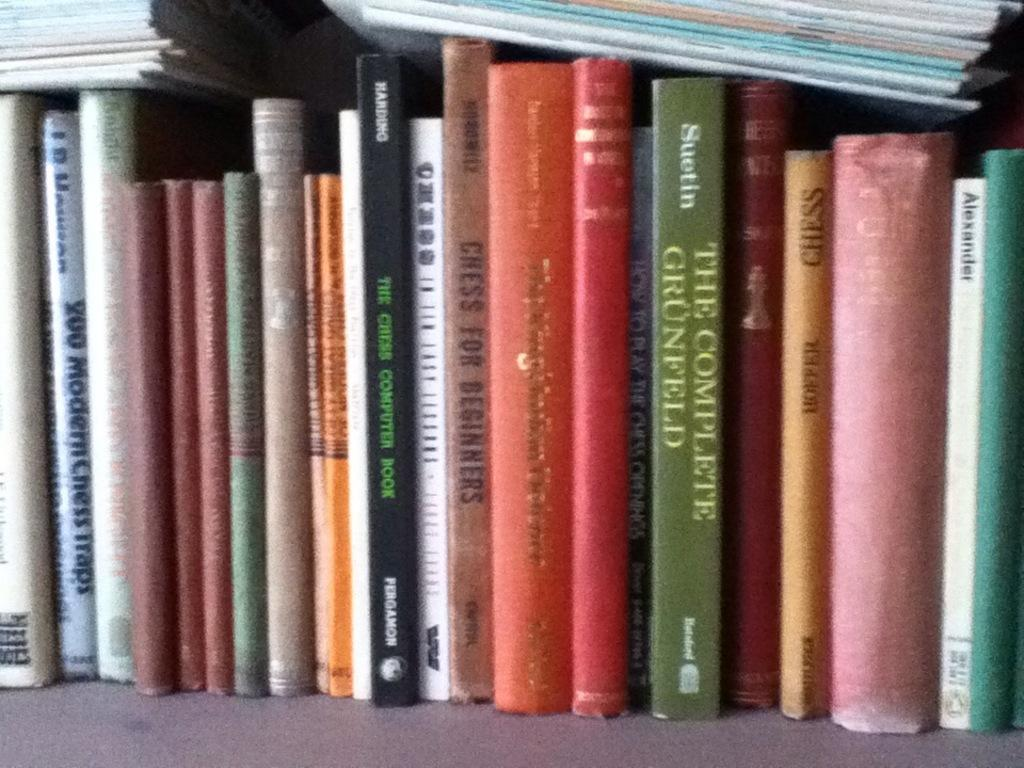<image>
Create a compact narrative representing the image presented. Many books are on a shelf including a green one that is titled The Complete Grunfeld. 